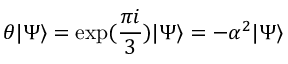Convert formula to latex. <formula><loc_0><loc_0><loc_500><loc_500>\theta | \Psi \rangle = \exp ( \frac { \pi i } { 3 } ) | \Psi \rangle = - \alpha ^ { 2 } | \Psi \rangle</formula> 